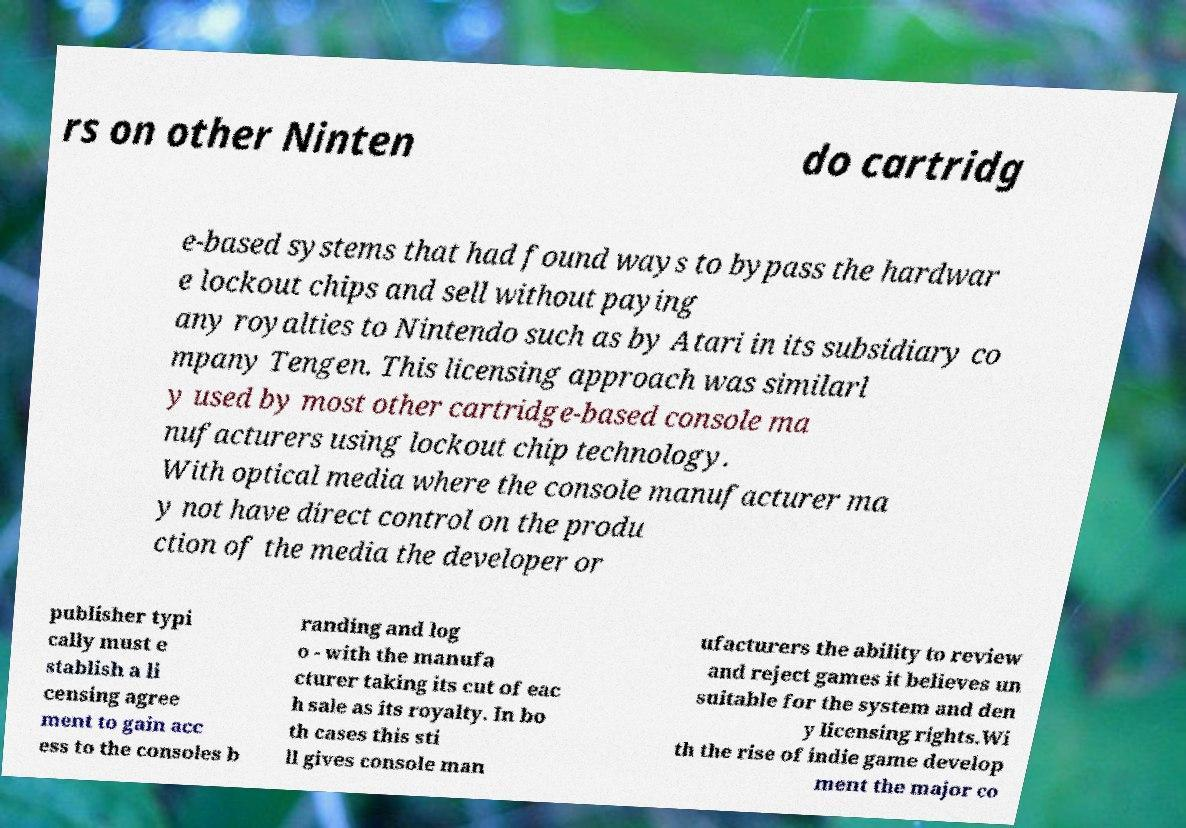There's text embedded in this image that I need extracted. Can you transcribe it verbatim? rs on other Ninten do cartridg e-based systems that had found ways to bypass the hardwar e lockout chips and sell without paying any royalties to Nintendo such as by Atari in its subsidiary co mpany Tengen. This licensing approach was similarl y used by most other cartridge-based console ma nufacturers using lockout chip technology. With optical media where the console manufacturer ma y not have direct control on the produ ction of the media the developer or publisher typi cally must e stablish a li censing agree ment to gain acc ess to the consoles b randing and log o - with the manufa cturer taking its cut of eac h sale as its royalty. In bo th cases this sti ll gives console man ufacturers the ability to review and reject games it believes un suitable for the system and den y licensing rights.Wi th the rise of indie game develop ment the major co 